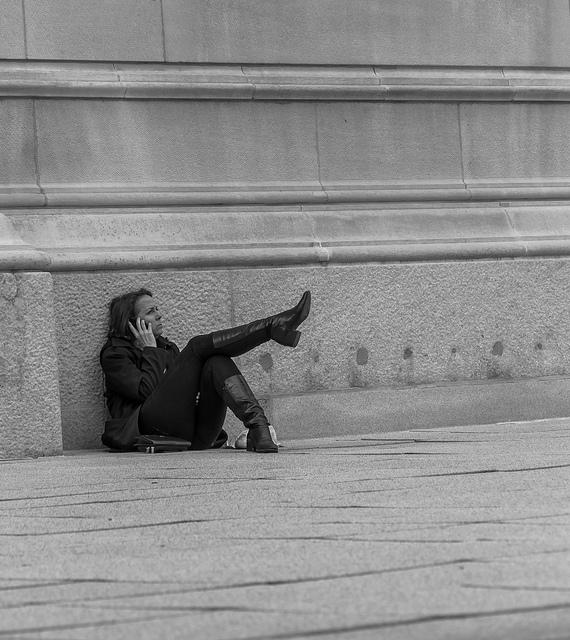Is she resting?
Give a very brief answer. Yes. Is she talking on her phone?
Give a very brief answer. Yes. Is this a color photo?
Give a very brief answer. No. 